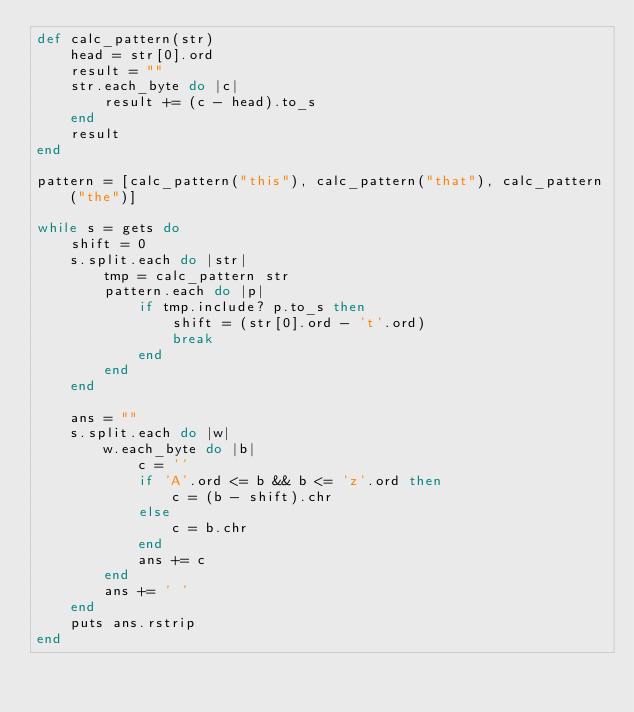Convert code to text. <code><loc_0><loc_0><loc_500><loc_500><_Ruby_>def calc_pattern(str)
    head = str[0].ord
    result = ""
    str.each_byte do |c|
        result += (c - head).to_s
    end
    result
end

pattern = [calc_pattern("this"), calc_pattern("that"), calc_pattern("the")]

while s = gets do
    shift = 0
    s.split.each do |str|
        tmp = calc_pattern str
        pattern.each do |p|
            if tmp.include? p.to_s then
                shift = (str[0].ord - 't'.ord)
                break
            end
        end
    end

    ans = ""
    s.split.each do |w|
        w.each_byte do |b|
            c = ''
            if 'A'.ord <= b && b <= 'z'.ord then
                c = (b - shift).chr
            else
                c = b.chr
            end
            ans += c
        end
        ans += ' '
    end
    puts ans.rstrip
end</code> 